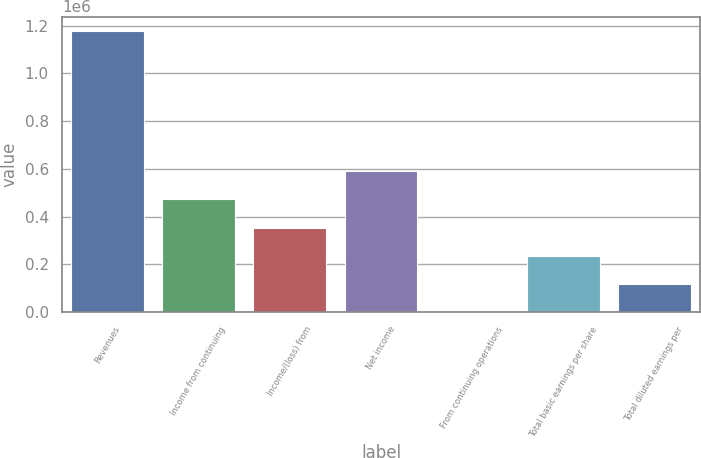Convert chart. <chart><loc_0><loc_0><loc_500><loc_500><bar_chart><fcel>Revenues<fcel>Income from continuing<fcel>Income/(loss) from<fcel>Net income<fcel>From continuing operations<fcel>Total basic earnings per share<fcel>Total diluted earnings per<nl><fcel>1.17968e+06<fcel>471872<fcel>353904<fcel>589839<fcel>0.91<fcel>235936<fcel>117969<nl></chart> 